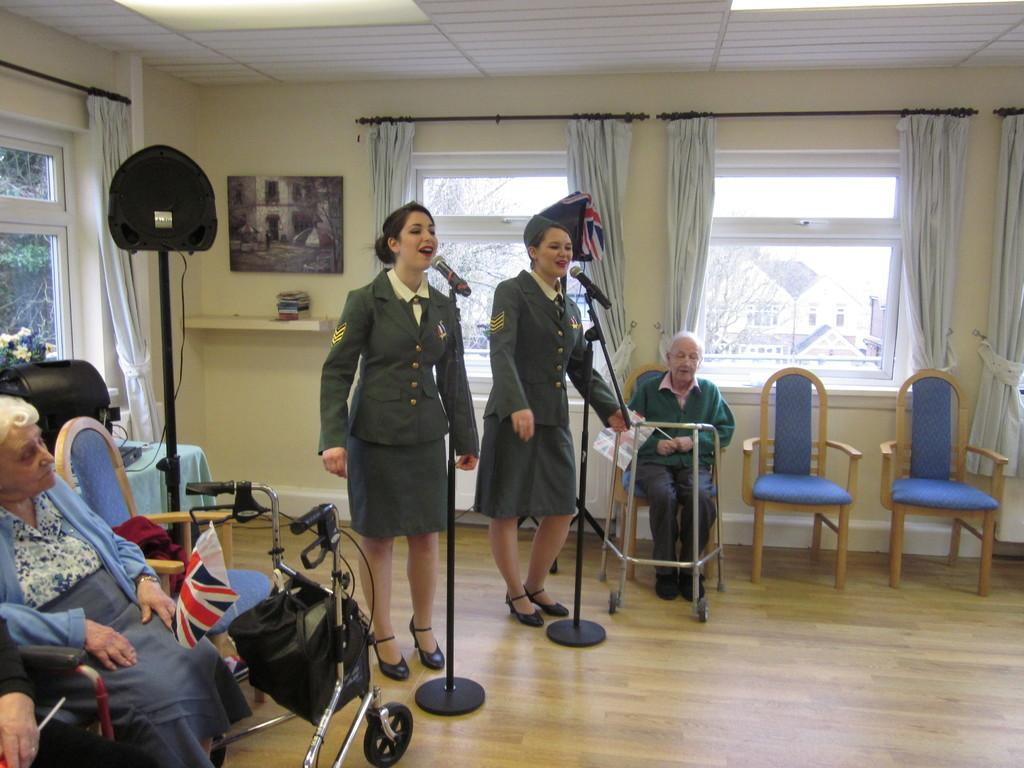What are the people in the image doing? There are people standing and sitting in the image. Can you describe the positions of the people in the image? Some people are standing, while others are sitting. What type of expansion is taking place in the image? There is no expansion mentioned or visible in the image. How many children are present in the image? The provided facts do not mention the presence of children in the image. 